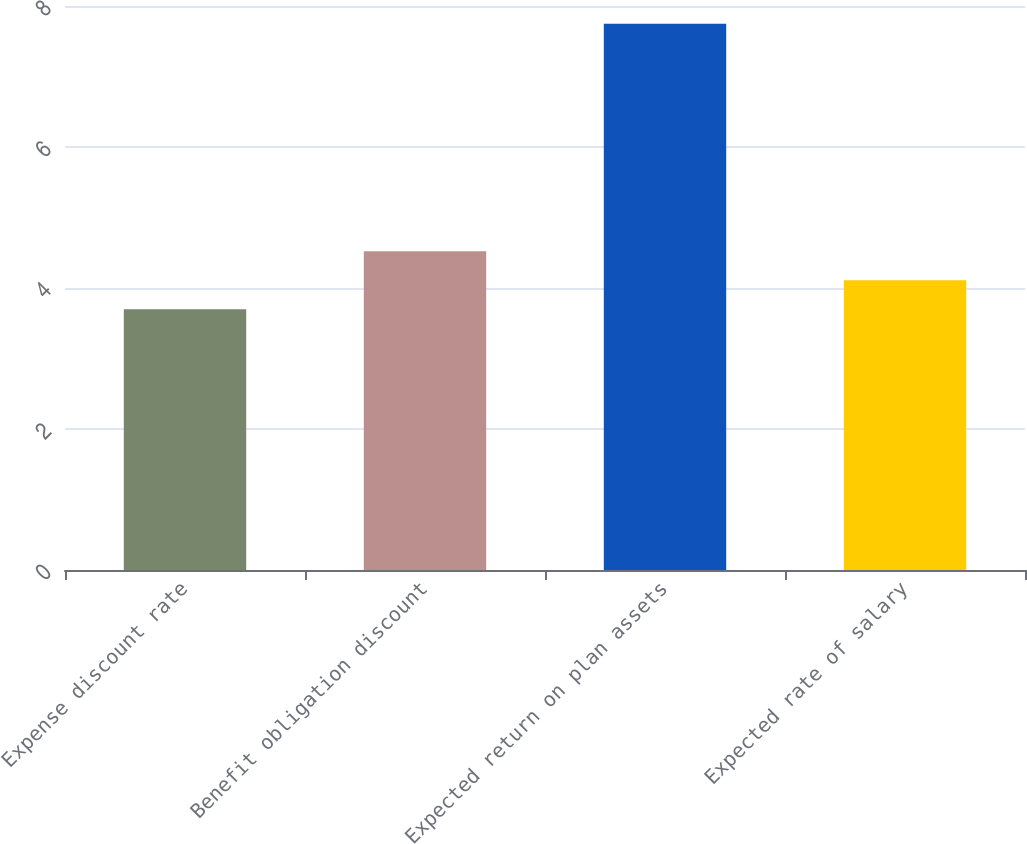Convert chart to OTSL. <chart><loc_0><loc_0><loc_500><loc_500><bar_chart><fcel>Expense discount rate<fcel>Benefit obligation discount<fcel>Expected return on plan assets<fcel>Expected rate of salary<nl><fcel>3.7<fcel>4.52<fcel>7.75<fcel>4.11<nl></chart> 